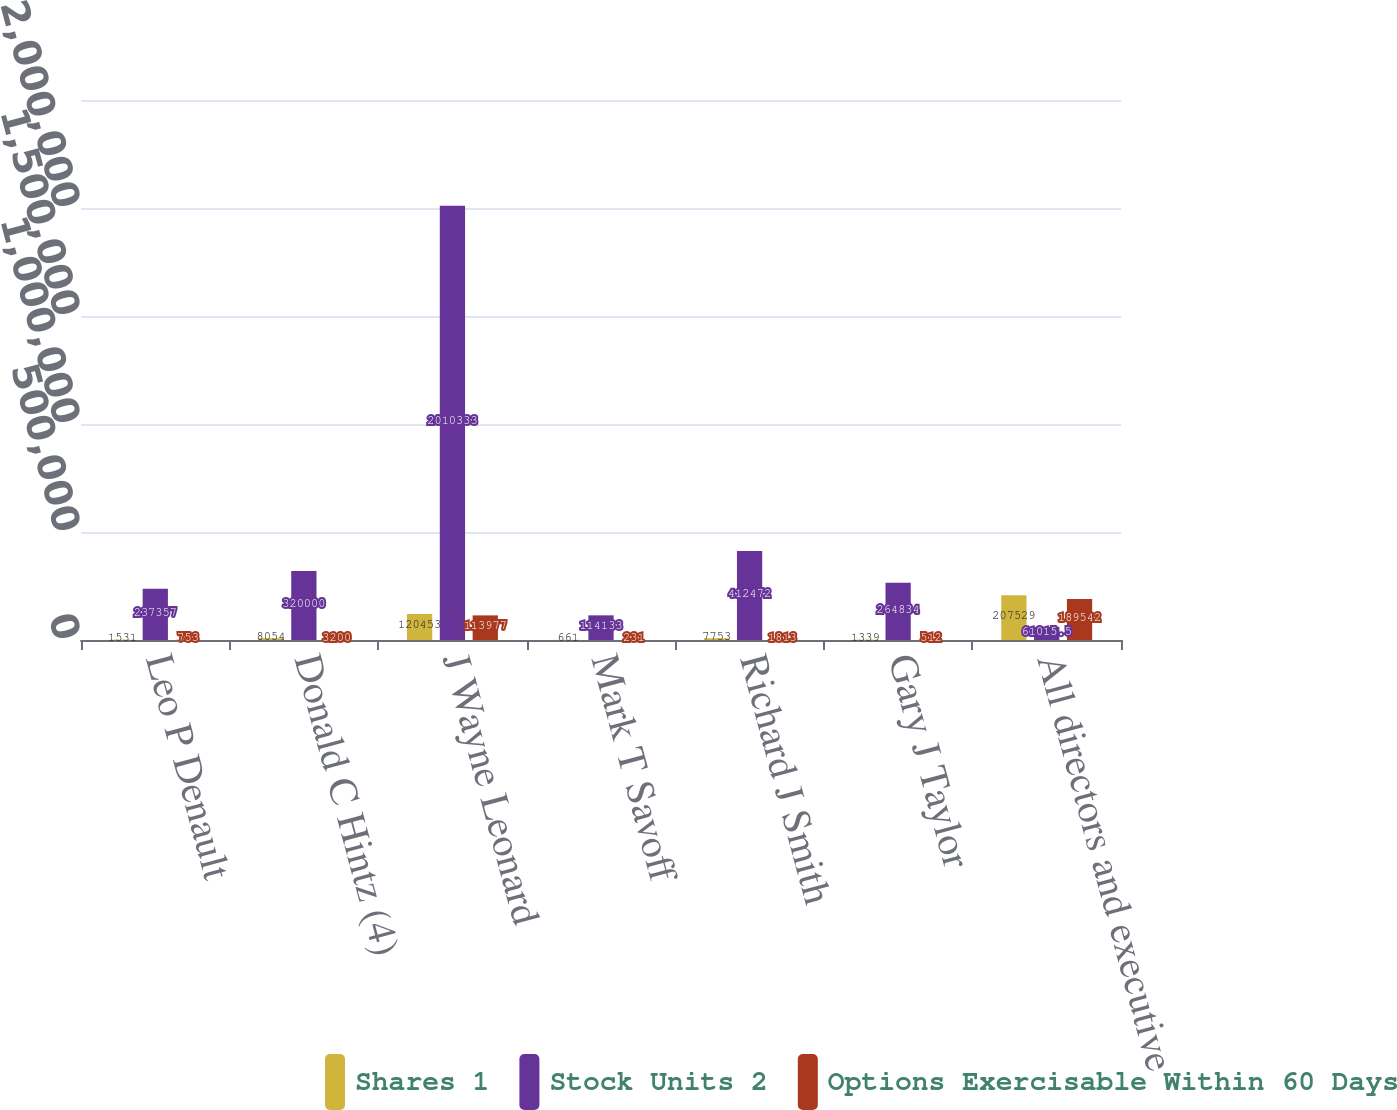<chart> <loc_0><loc_0><loc_500><loc_500><stacked_bar_chart><ecel><fcel>Leo P Denault<fcel>Donald C Hintz (4)<fcel>J Wayne Leonard<fcel>Mark T Savoff<fcel>Richard J Smith<fcel>Gary J Taylor<fcel>All directors and executive<nl><fcel>Shares 1<fcel>1531<fcel>8054<fcel>120453<fcel>661<fcel>7753<fcel>1339<fcel>207529<nl><fcel>Stock Units 2<fcel>237357<fcel>320000<fcel>2.01033e+06<fcel>114133<fcel>412472<fcel>264834<fcel>61015.5<nl><fcel>Options Exercisable Within 60 Days<fcel>753<fcel>3200<fcel>113977<fcel>231<fcel>1813<fcel>512<fcel>189542<nl></chart> 